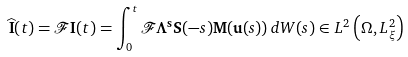<formula> <loc_0><loc_0><loc_500><loc_500>\widehat { \mathbf I } ( t ) = \mathcal { F } \mathbf I ( t ) = \int _ { 0 } ^ { t } \mathcal { F } \mathbf \Lambda ^ { \mathbf s } \mathbf S ( - s ) \mathbf M ( \mathbf u ( s ) ) \, d W ( s ) \in L ^ { 2 } \left ( \Omega , L ^ { 2 } _ { \xi } \right )</formula> 